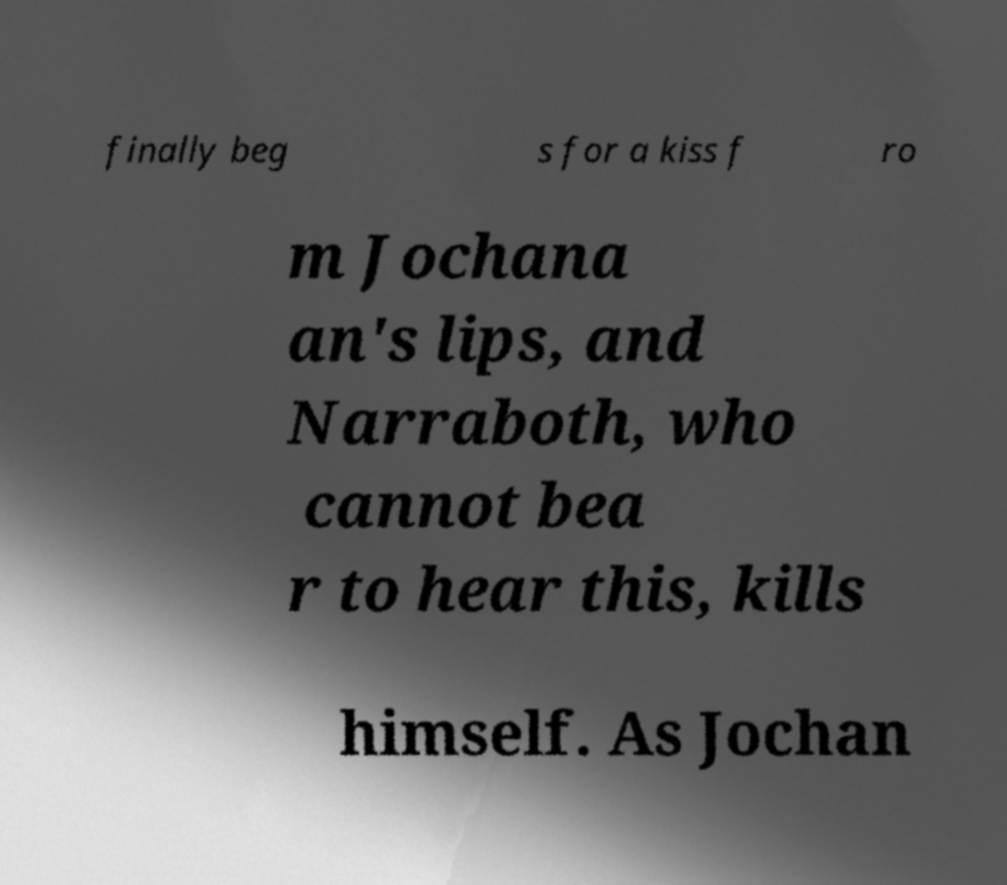Can you read and provide the text displayed in the image?This photo seems to have some interesting text. Can you extract and type it out for me? finally beg s for a kiss f ro m Jochana an's lips, and Narraboth, who cannot bea r to hear this, kills himself. As Jochan 